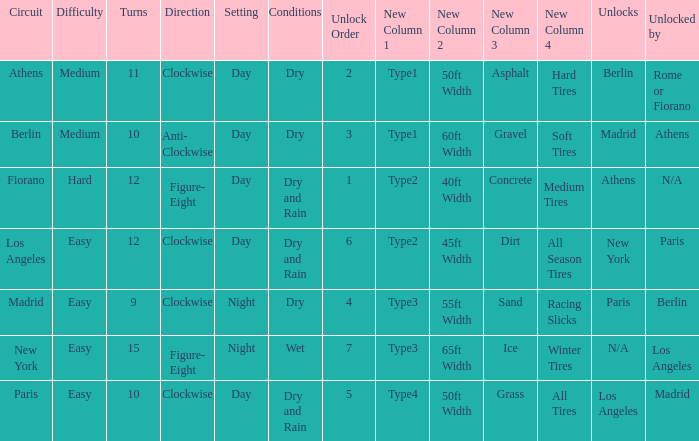Can you parse all the data within this table? {'header': ['Circuit', 'Difficulty', 'Turns', 'Direction', 'Setting', 'Conditions', 'Unlock Order', 'New Column 1', 'New Column 2', 'New Column 3', 'New Column 4', 'Unlocks', 'Unlocked by'], 'rows': [['Athens', 'Medium', '11', 'Clockwise', 'Day', 'Dry', '2', 'Type1', '50ft Width', 'Asphalt', 'Hard Tires', 'Berlin', 'Rome or Fiorano'], ['Berlin', 'Medium', '10', 'Anti- Clockwise', 'Day', 'Dry', '3', 'Type1', '60ft Width', 'Gravel', 'Soft Tires', 'Madrid', 'Athens'], ['Fiorano', 'Hard', '12', 'Figure- Eight', 'Day', 'Dry and Rain', '1', 'Type2', '40ft Width', 'Concrete', 'Medium Tires', 'Athens', 'N/A'], ['Los Angeles', 'Easy', '12', 'Clockwise', 'Day', 'Dry and Rain', '6', 'Type2', '45ft Width', 'Dirt', 'All Season Tires', 'New York', 'Paris'], ['Madrid', 'Easy', '9', 'Clockwise', 'Night', 'Dry', '4', 'Type3', '55ft Width', 'Sand', 'Racing Slicks', 'Paris', 'Berlin'], ['New York', 'Easy', '15', 'Figure- Eight', 'Night', 'Wet', '7', 'Type3', '65ft Width', 'Ice', 'Winter Tires', 'N/A', 'Los Angeles'], ['Paris', 'Easy', '10', 'Clockwise', 'Day', 'Dry and Rain', '5', 'Type4', '50ft Width', 'Grass', 'All Tires', 'Los Angeles', 'Madrid']]} What is the setting for the hard difficulty? Day. 